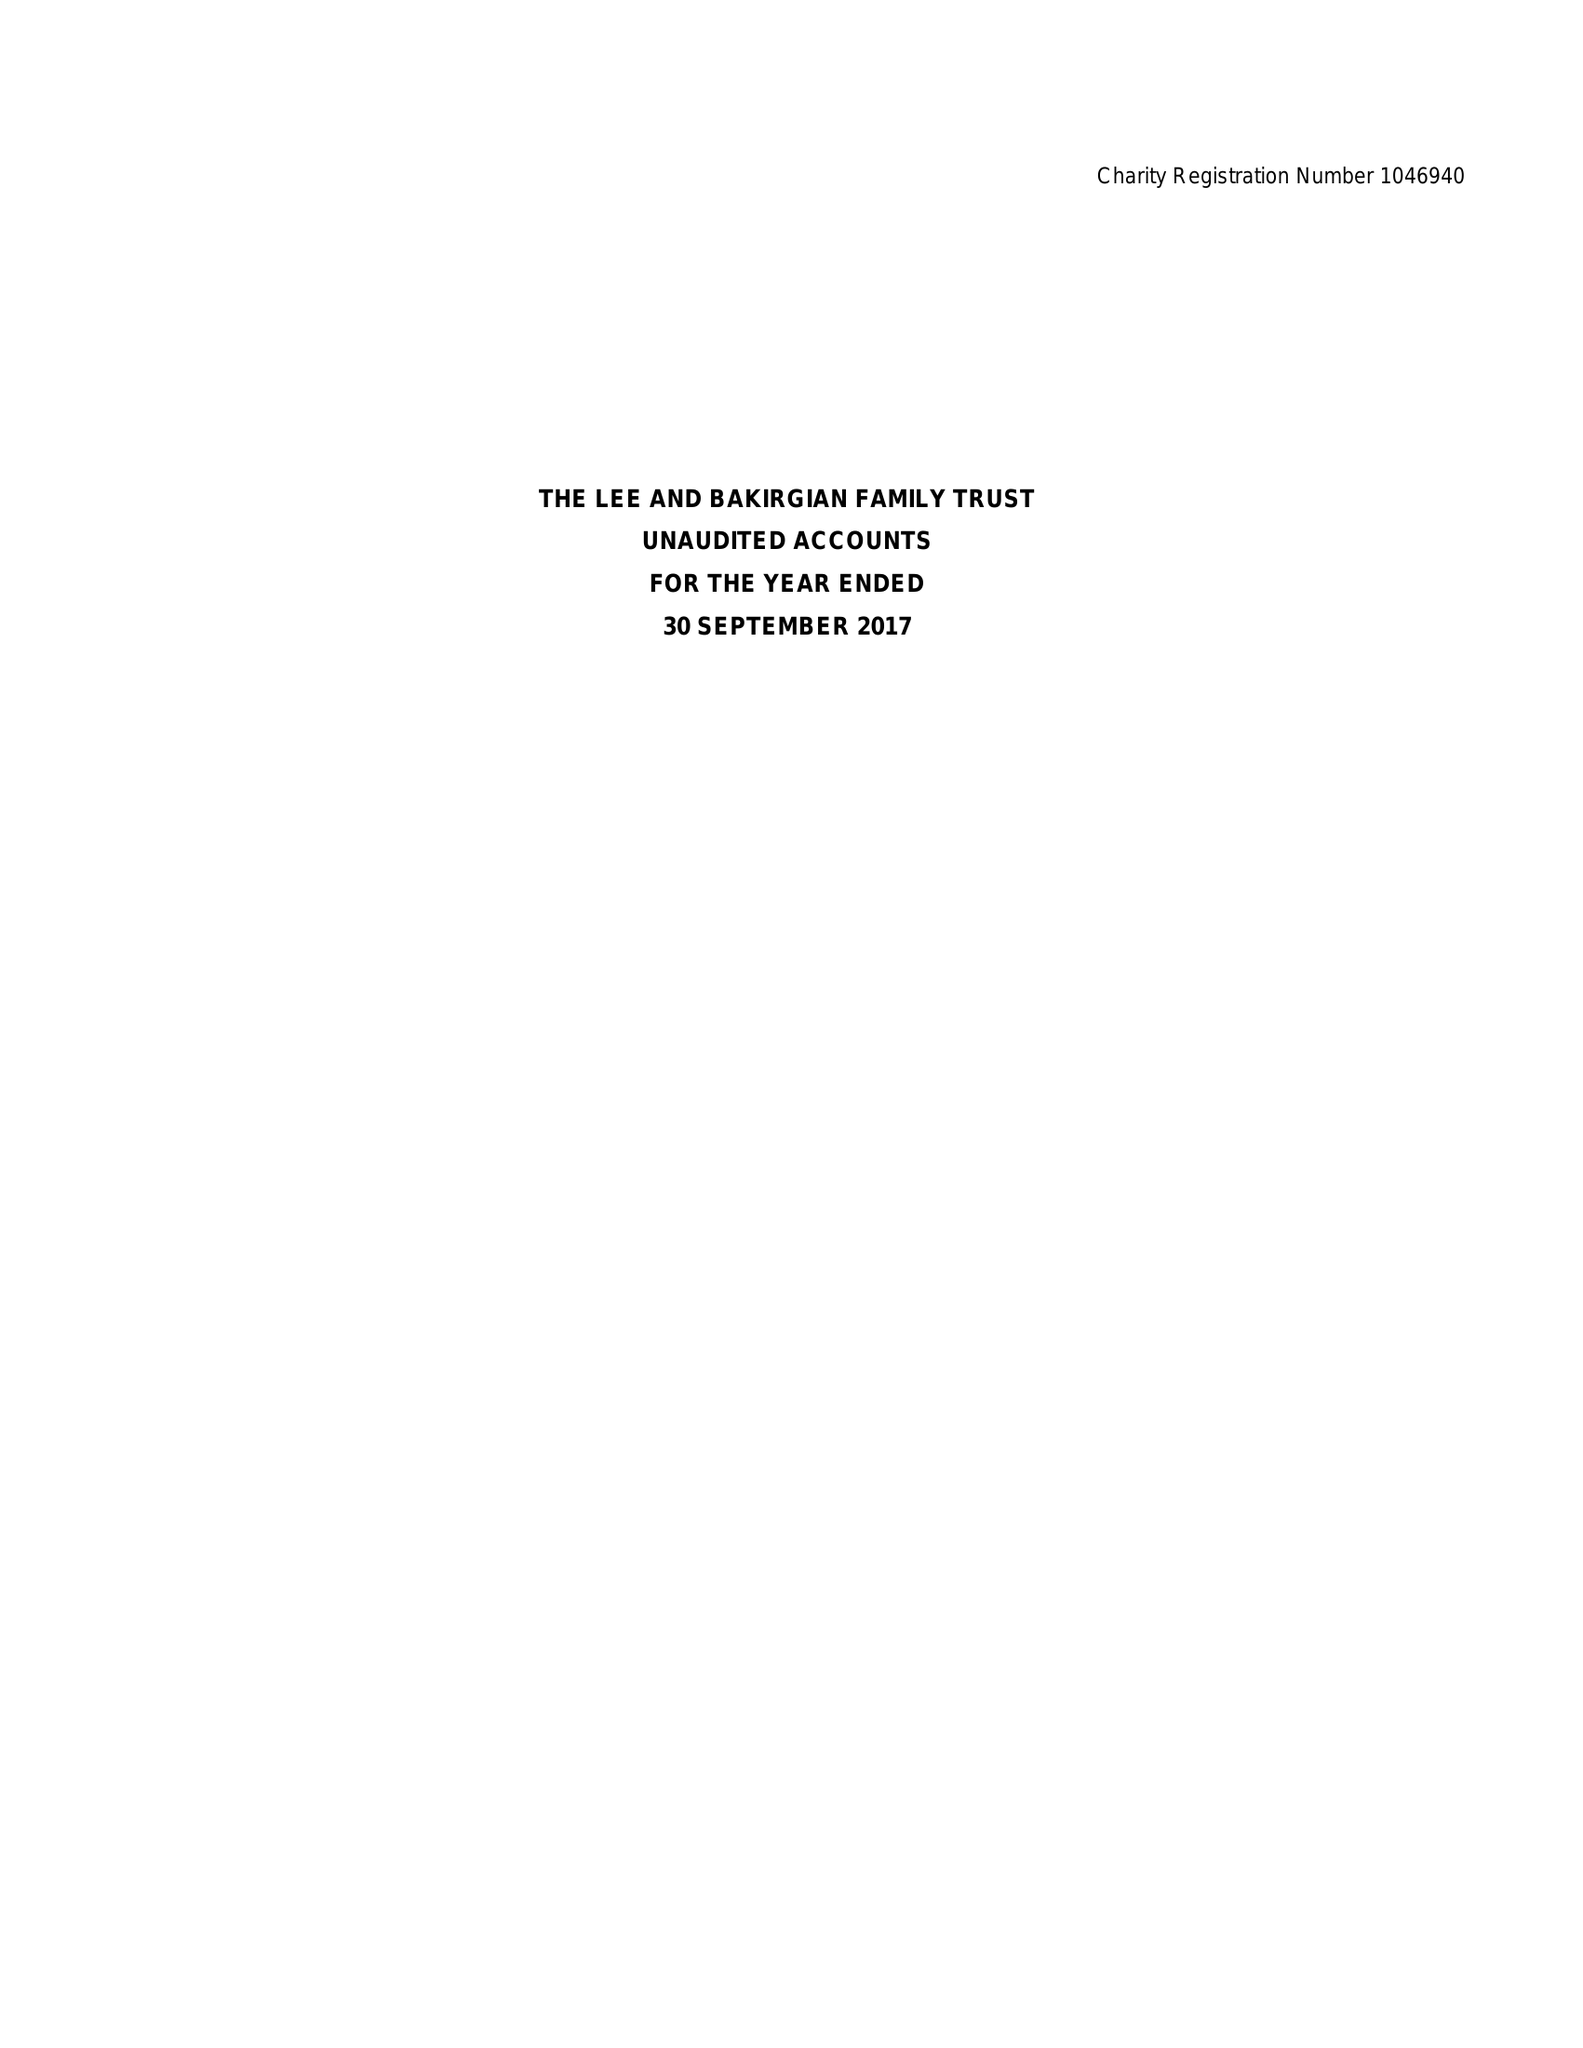What is the value for the charity_number?
Answer the question using a single word or phrase. 1046940 